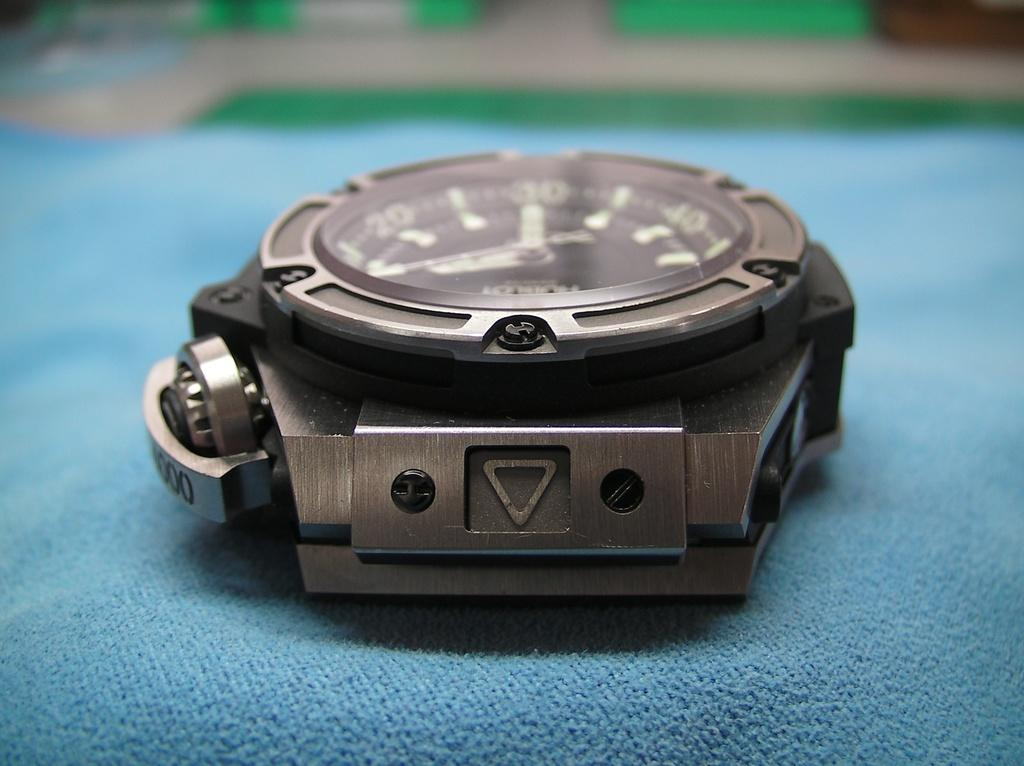<image>
Provide a brief description of the given image. A watch without a band has a brand name that includes the letter "O". 